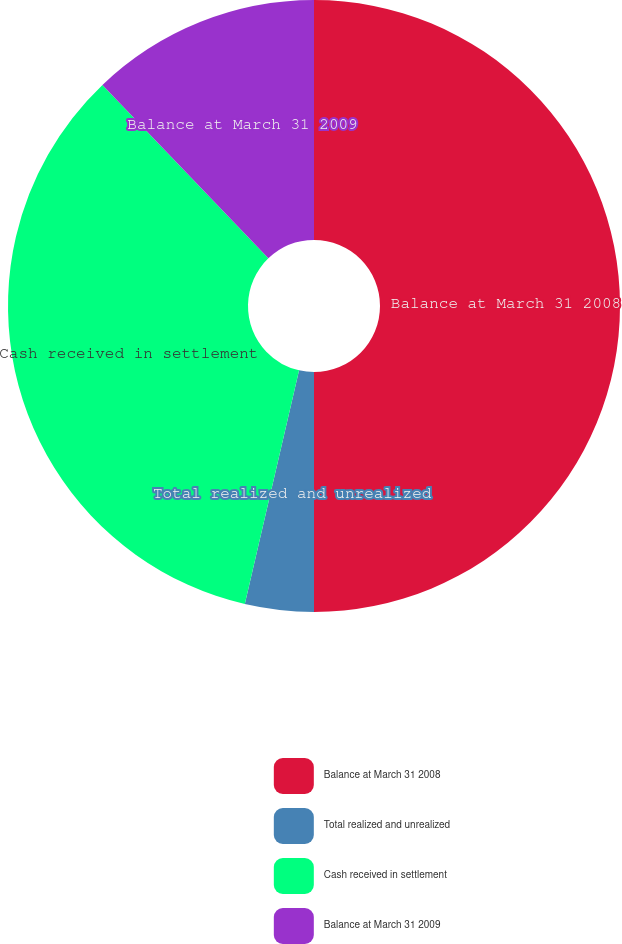Convert chart. <chart><loc_0><loc_0><loc_500><loc_500><pie_chart><fcel>Balance at March 31 2008<fcel>Total realized and unrealized<fcel>Cash received in settlement<fcel>Balance at March 31 2009<nl><fcel>50.0%<fcel>3.63%<fcel>34.22%<fcel>12.15%<nl></chart> 